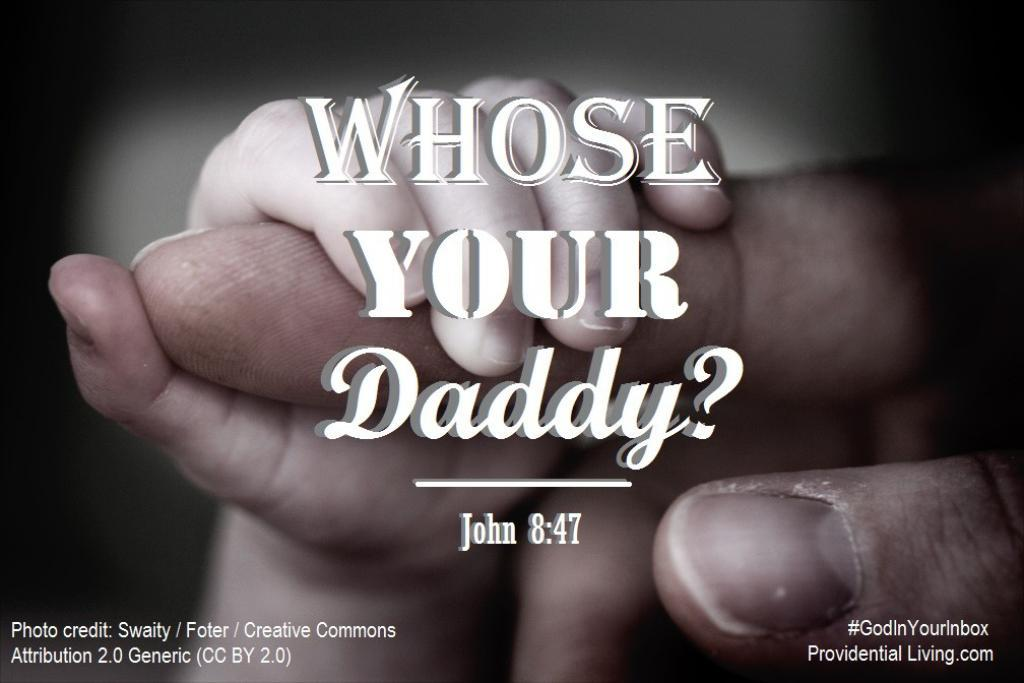What body part is visible in the image? There are hands visible in the image. What else can be seen in the image besides hands? There are logos and quotations in the image. How many eyes can be seen in the image? There are no eyes visible in the image; only hands, logos, and quotations are present. What type of pollution is depicted in the image? There is no depiction of pollution in the image. How many friends are visible in the image? There is no reference to friends in the image. 